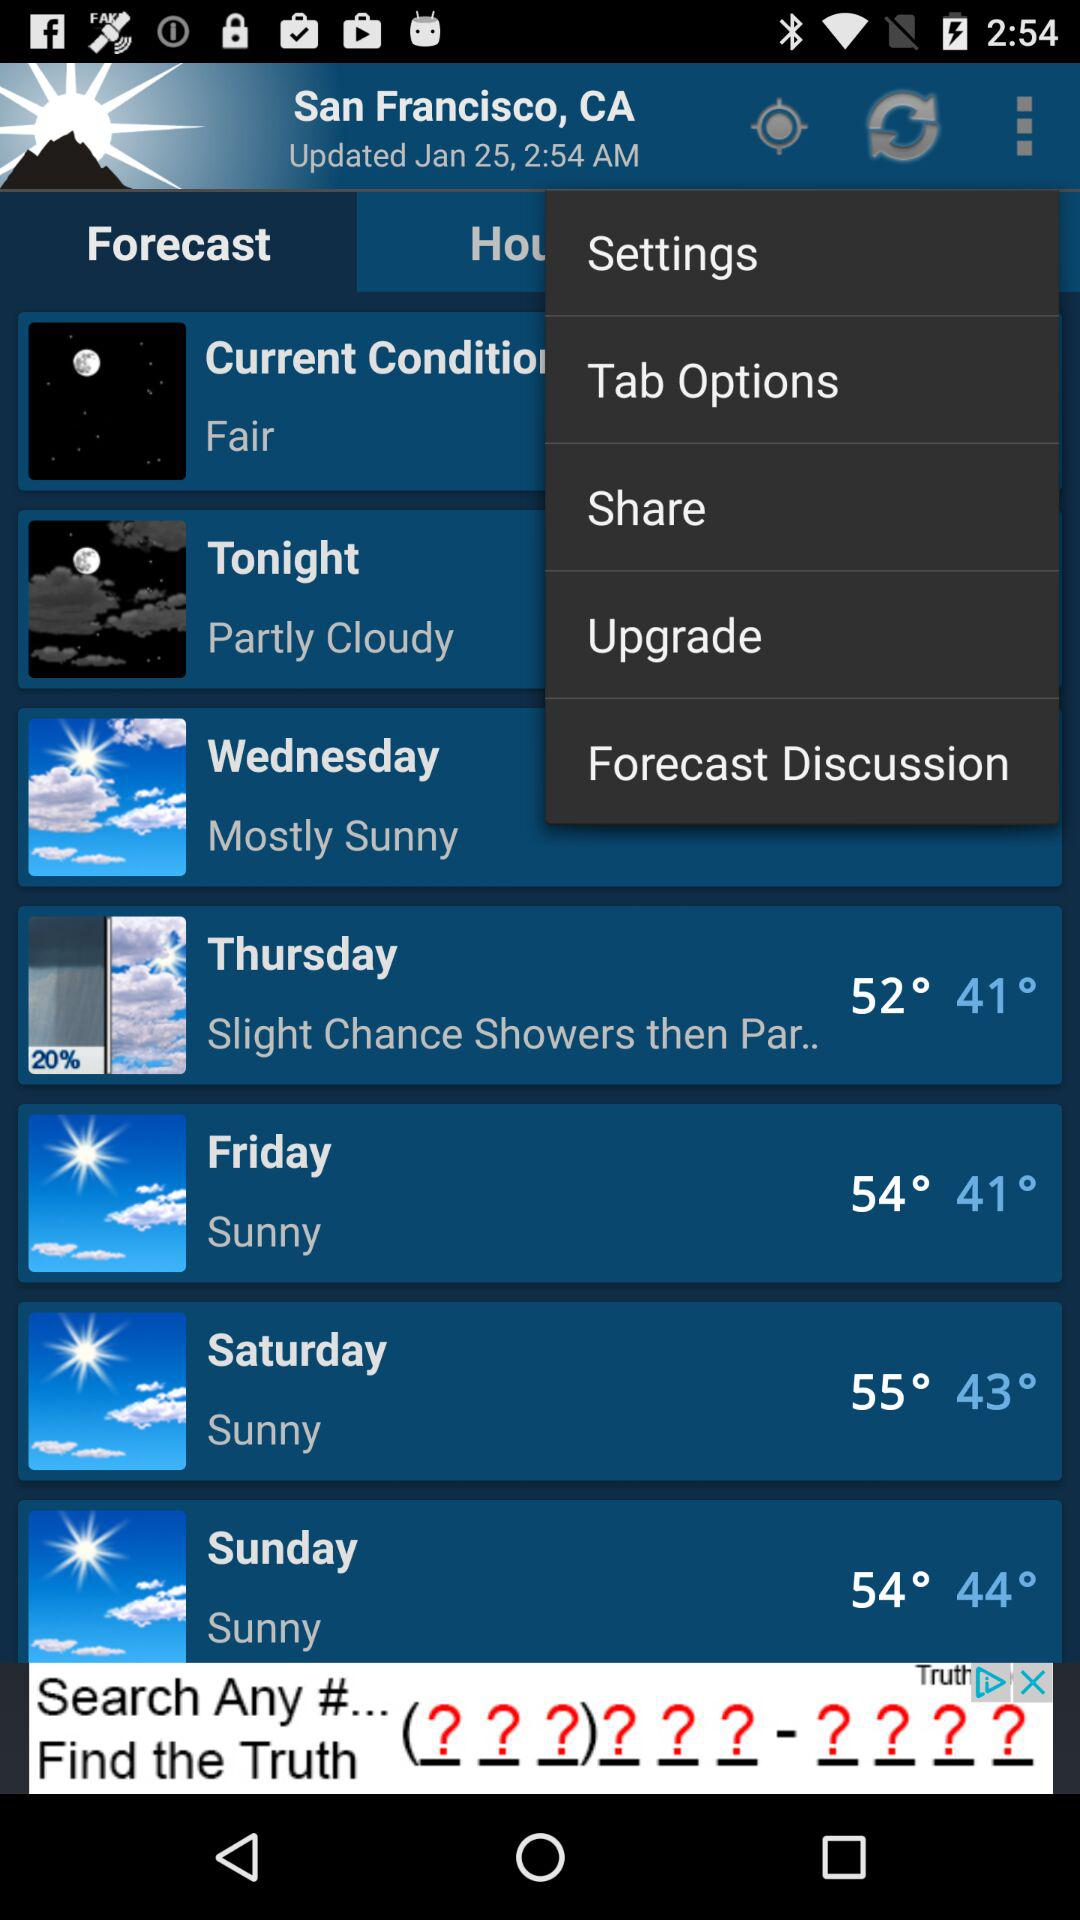How is the weather on Friday? The weather is sunny. 